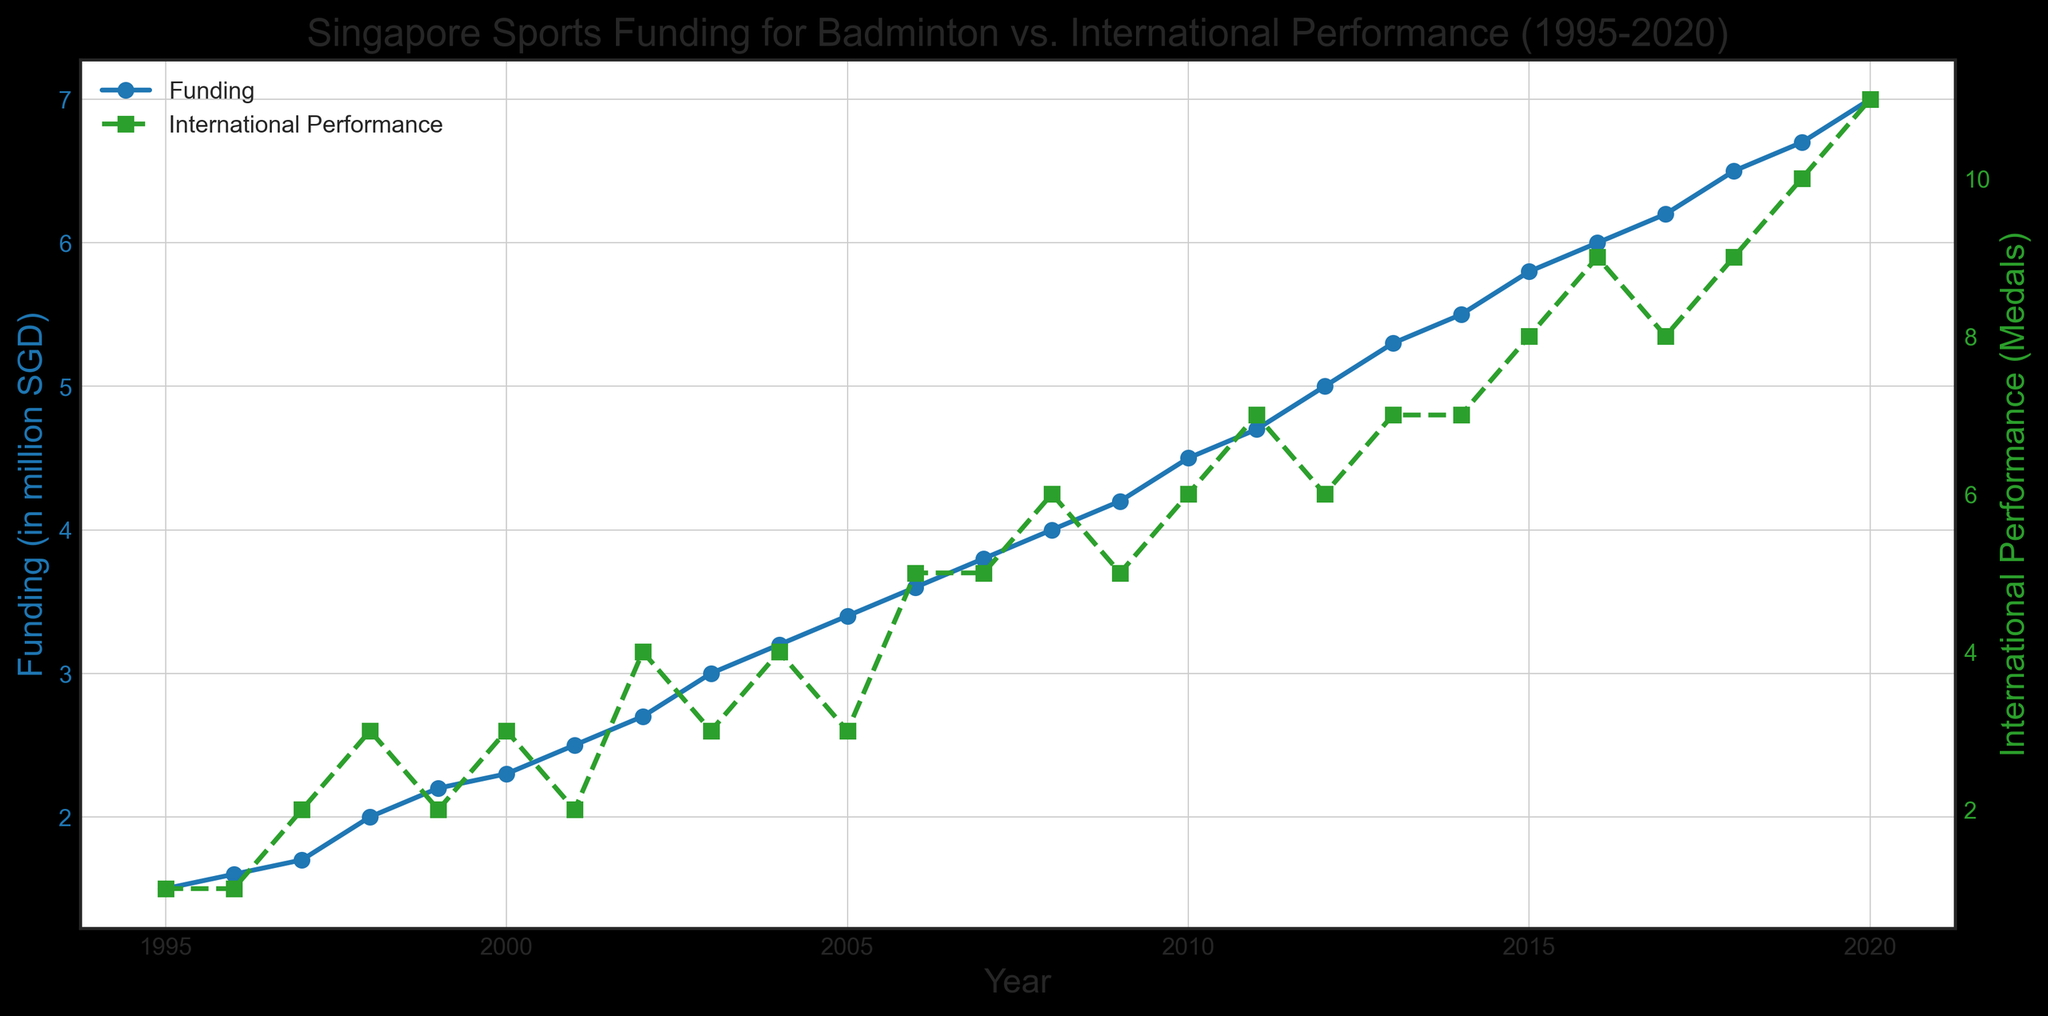What is the highest funding allocated for badminton between 1995 and 2020? Look for the highest value on the Funding (in million SGD) line (represented by the blue line) in the figure. The highest value is given in 2020.
Answer: 7.0 million SGD Which year had the highest international performance in terms of medals won? Observe the peak of the International Performance (Medals) line (represented by the green line) in the figure. The highest point occurs in 2020.
Answer: 2020 In what year did funding for badminton first exceed 5 million SGD? Identify the point on the Funding (in million SGD) line where the values first surpass 5 million SGD. This occurs in 2012.
Answer: 2012 Compare the international performance in the year 2000 to that in 2020. Check the International Performance (Medals) values for 2000 and 2020 on the green line. In 2000, the performance is 3 medals, whereas in 2020 it is 11 medals.
Answer: 3 medals in 2000, 11 medals in 2020 How much did the funding increase from 1995 to 2020? Subtract the funding value of 1995 from that of 2020: 7.0 million SGD in 2020 minus 1.5 million SGD in 1995.
Answer: 5.5 million SGD What is the general trend observed in funding allocation and international performance from 1995 to 2020? Both the funding allocation (blue line) and international performance (green line) show an upward trend over the years. The funding and performance indicators both increase steadily from 1995 to 2020.
Answer: Upward trend Between 2005 and 2010, how many years did both funding and international performance increase? Compare the funding (blue line) and international performance (green line) year by year between 2005 and 2010. Both increased in 2006, 2008, and 2010.
Answer: 3 years What was the funding amount in the year with the lowest international performance? Identify the year with the lowest international performance (1 medal in 1995 and 1996) in the green line and then check the corresponding funding value on the blue line. Both years have funding values of 1.5 million (1995) and 1.6 million (1996).
Answer: 1.5 million SGD in 1995, 1.6 million SGD in 1996 Does the increase in funding always result in an increase in international performance? Observe both lines over the span of years. Noticeable exceptions include 1999 and 2001 where funding increased but the performance dropped.
Answer: No Calculate the average number of medals won from 2010 to 2020. Sum the number of medals from 2010 to 2020 and divide by the number of years: (6+7+6+7+7+8+9+8+9+10+11)/11 = 8
Answer: 8 